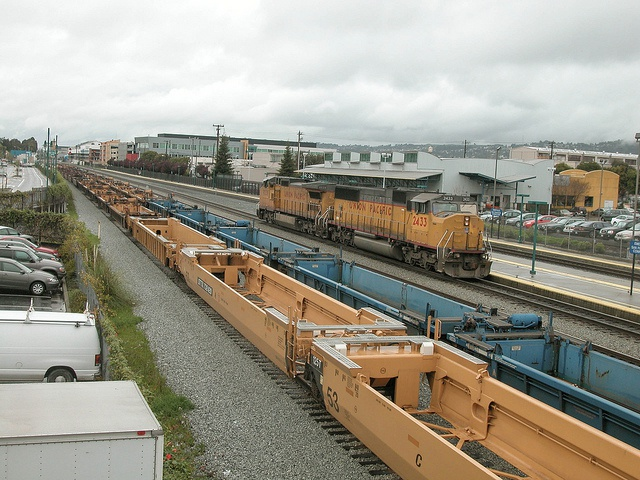Describe the objects in this image and their specific colors. I can see train in white, tan, olive, and maroon tones, train in white, gray, black, blue, and teal tones, truck in white, darkgray, lightgray, and gray tones, train in white, black, and gray tones, and car in white, gray, black, darkgray, and lightgray tones in this image. 